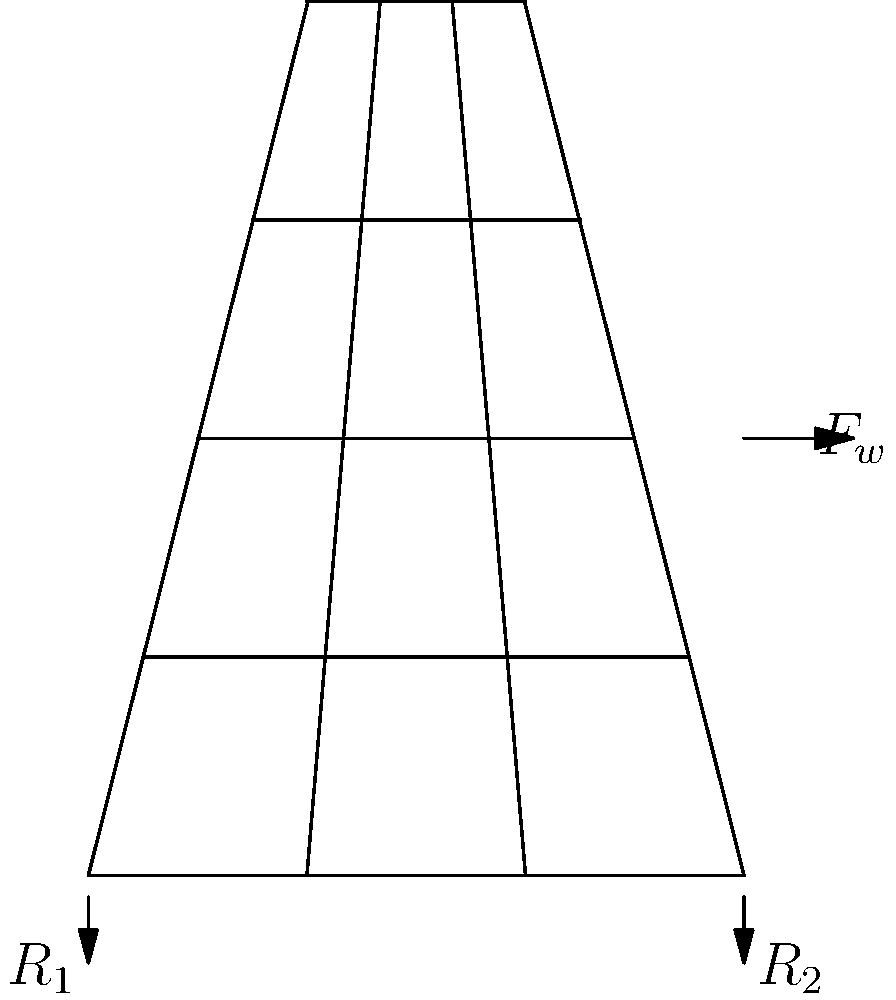In a typical Japanese pagoda structure as shown, what is the primary factor that contributes to its ability to withstand lateral forces such as those from strong winds or earthquakes? To understand the stress analysis of a typical Japanese pagoda structure, we need to consider several factors:

1. Central column (shinbashira): Traditional Japanese pagodas have a central wooden column that runs from the base to the top. This column is not fixed to the rest of the structure but can move independently.

2. Flexibility: The entire structure is designed to be flexible, allowing it to sway during earthquakes or strong winds.

3. Weight distribution: Each level of the pagoda is progressively lighter as we move up, with the heaviest part at the base.

4. Interlocking joints: Traditional Japanese carpentry uses complex joinery techniques that allow for movement while maintaining structural integrity.

5. Pendulum effect: The central column acts as a counterweight, similar to a pendulum. When lateral forces ($F_w$) act on the structure, the column's mass helps to stabilize the pagoda by opposing the motion.

6. Energy dissipation: The flexible nature of the structure and the ability of joints to slightly move allows for energy dissipation during seismic events.

The primary factor that contributes to the pagoda's ability to withstand lateral forces is the central column (shinbashira) acting as a tuned mass damper. This column, combined with the overall flexible design, allows the structure to sway and dissipate energy from lateral forces effectively.

The reactions at the base ($R_1$ and $R_2$) counteract the lateral force ($F_w$) and the structure's weight. The central column's movement helps to reduce the magnitude of these reactions by opposing the motion of the rest of the structure.
Answer: Central column (shinbashira) acting as a tuned mass damper 